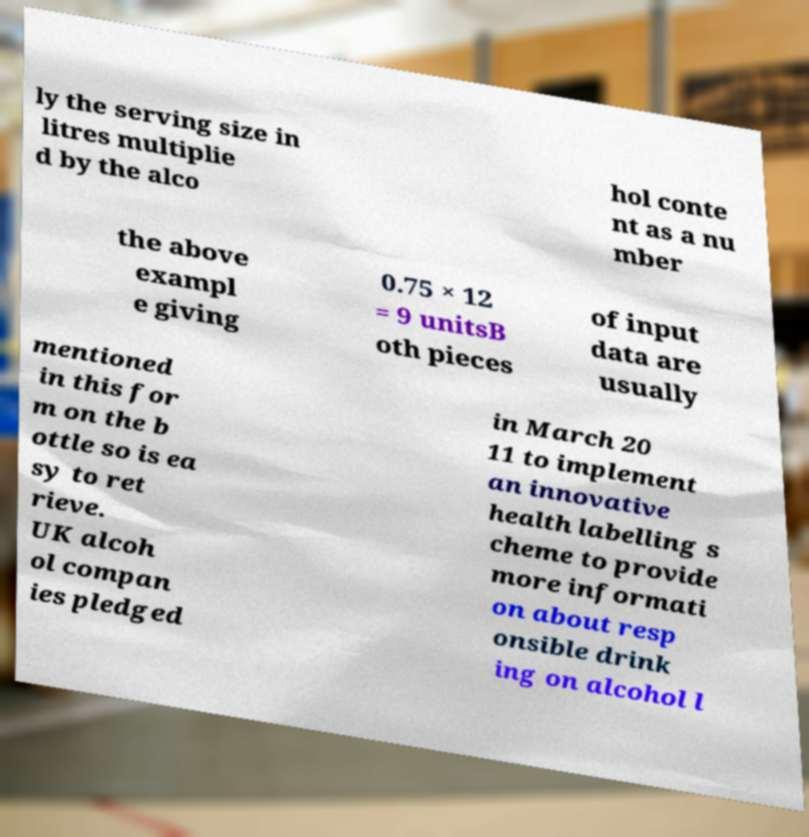Could you extract and type out the text from this image? ly the serving size in litres multiplie d by the alco hol conte nt as a nu mber the above exampl e giving 0.75 × 12 = 9 unitsB oth pieces of input data are usually mentioned in this for m on the b ottle so is ea sy to ret rieve. UK alcoh ol compan ies pledged in March 20 11 to implement an innovative health labelling s cheme to provide more informati on about resp onsible drink ing on alcohol l 